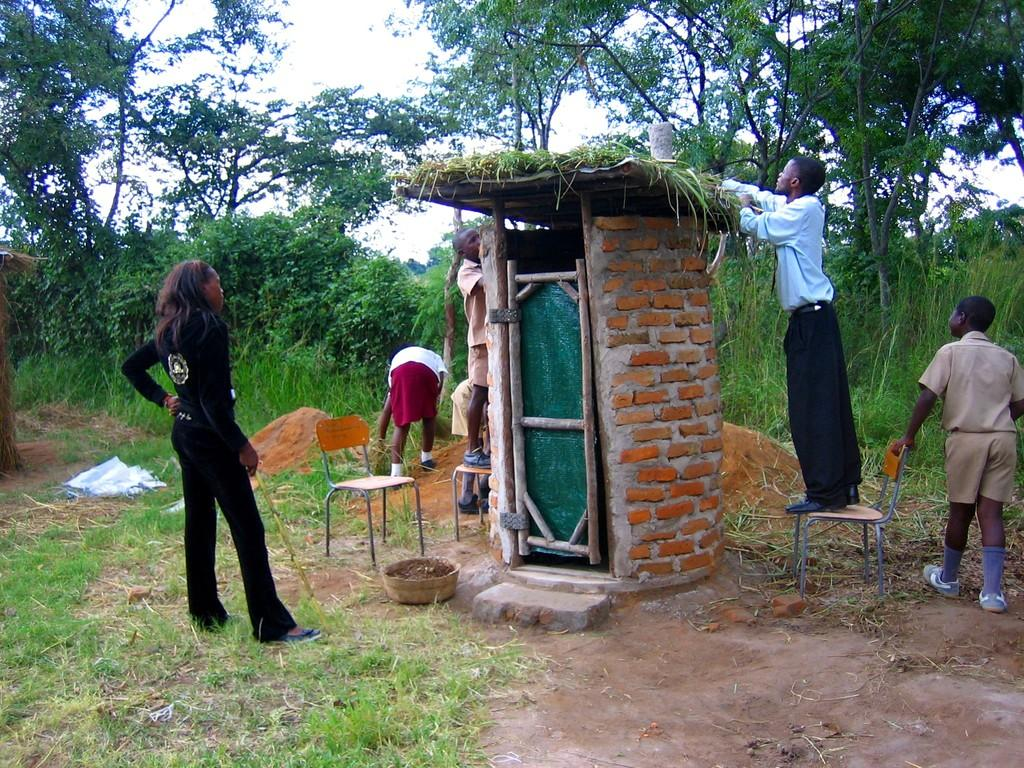What is the main subject of the image? There is a building at the center of the image. What is happening around the building? People are standing around the building. What can be seen in the background of the image? There are trees at the back side of the image. What is visible in the sky? The sky is visible in the image. What type of surface is present in the image? There is grass on the surface. How many fingers are visible on the people standing around the building? There is no information about the number of fingers visible on the people in the image. Are there any cows present in the image? There is no mention of cows in the image; the main subjects are the building, people, trees, sky, and grass. 